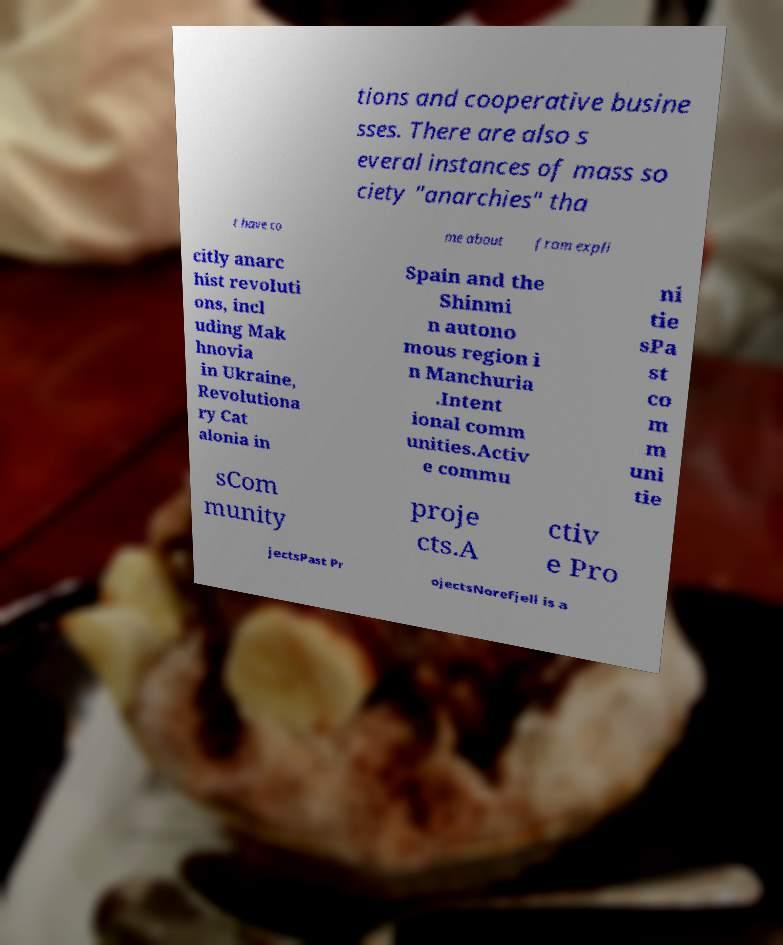I need the written content from this picture converted into text. Can you do that? tions and cooperative busine sses. There are also s everal instances of mass so ciety "anarchies" tha t have co me about from expli citly anarc hist revoluti ons, incl uding Mak hnovia in Ukraine, Revolutiona ry Cat alonia in Spain and the Shinmi n autono mous region i n Manchuria .Intent ional comm unities.Activ e commu ni tie sPa st co m m uni tie sCom munity proje cts.A ctiv e Pro jectsPast Pr ojectsNorefjell is a 